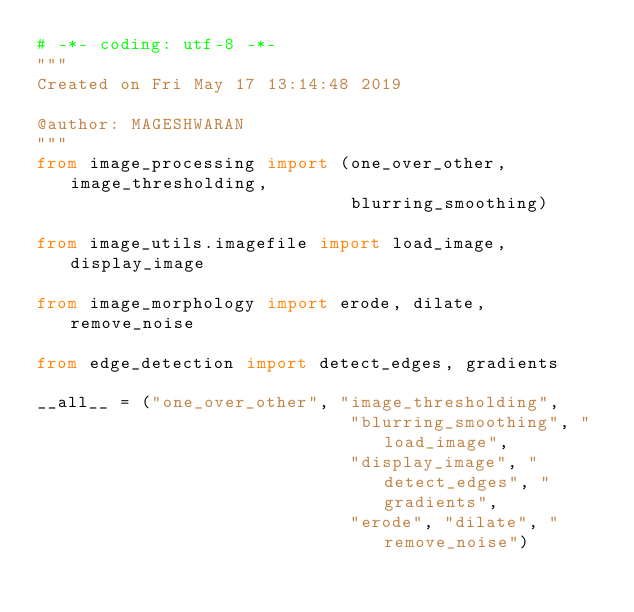<code> <loc_0><loc_0><loc_500><loc_500><_Python_># -*- coding: utf-8 -*-
"""
Created on Fri May 17 13:14:48 2019

@author: MAGESHWARAN
"""
from image_processing import (one_over_other, image_thresholding,
                              blurring_smoothing)

from image_utils.imagefile import load_image, display_image

from image_morphology import erode, dilate, remove_noise

from edge_detection import detect_edges, gradients

__all__ = ("one_over_other", "image_thresholding",
                              "blurring_smoothing", "load_image",
                              "display_image", "detect_edges", "gradients",
                              "erode", "dilate", "remove_noise")</code> 